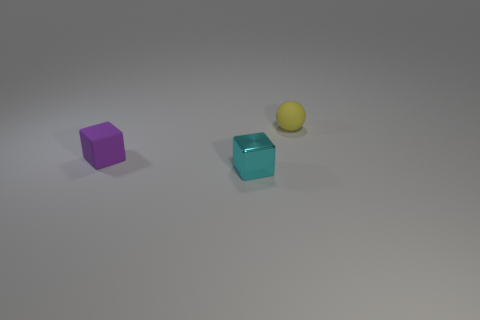There is a rubber thing in front of the yellow thing; does it have the same shape as the tiny cyan metallic thing?
Your answer should be very brief. Yes. There is a thing that is both right of the matte cube and in front of the tiny yellow matte thing; what is its color?
Your response must be concise. Cyan. What number of green matte cylinders are the same size as the matte ball?
Your answer should be compact. 0. What material is the yellow ball?
Make the answer very short. Rubber. Are there any small purple matte cubes to the left of the cyan shiny cube?
Ensure brevity in your answer.  Yes. Is the number of yellow things that are behind the small cyan metal cube less than the number of things to the right of the rubber cube?
Your answer should be very brief. Yes. Are there any small yellow balls that have the same material as the small purple thing?
Your answer should be compact. Yes. Are the tiny cyan cube and the purple object made of the same material?
Keep it short and to the point. No. There is another cube that is the same size as the cyan block; what color is it?
Your answer should be very brief. Purple. How many other things are the same shape as the purple object?
Ensure brevity in your answer.  1. 